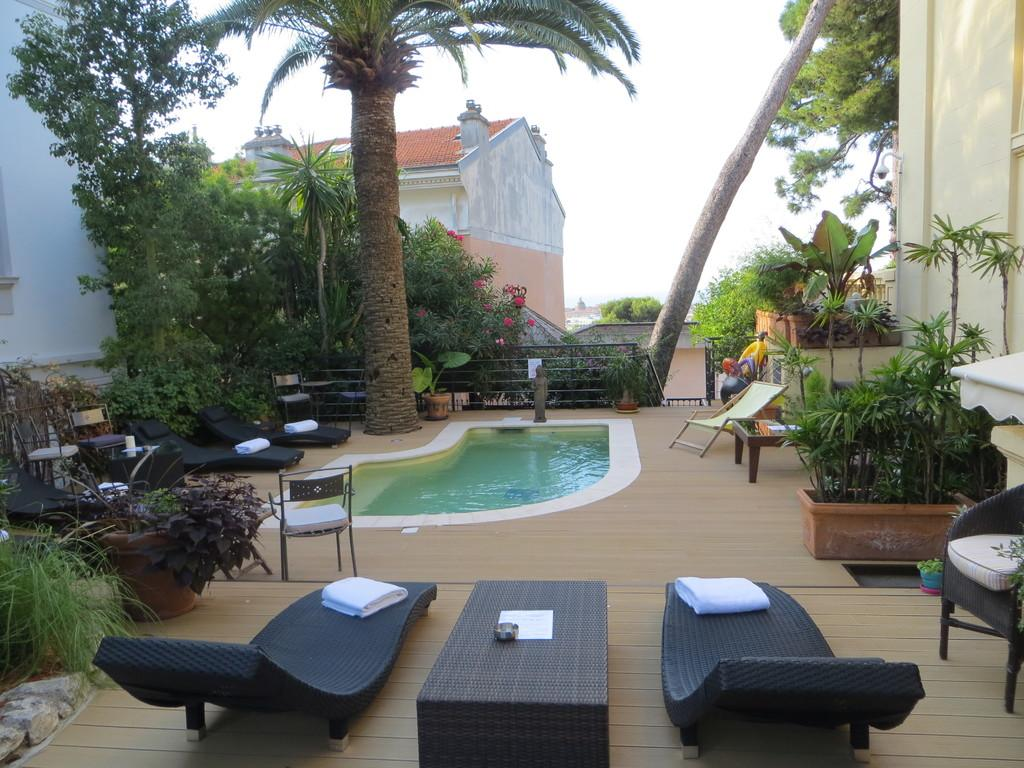What type of water feature is present in the image? There is a small swimming pool in the image. What type of vegetation can be seen in the image? There are green color plants and trees in the image. What is visible at the top of the image? The sky is visible at the top of the image. How much does the squirrel weigh in the image? There is no squirrel present in the image, so its weight cannot be determined. 